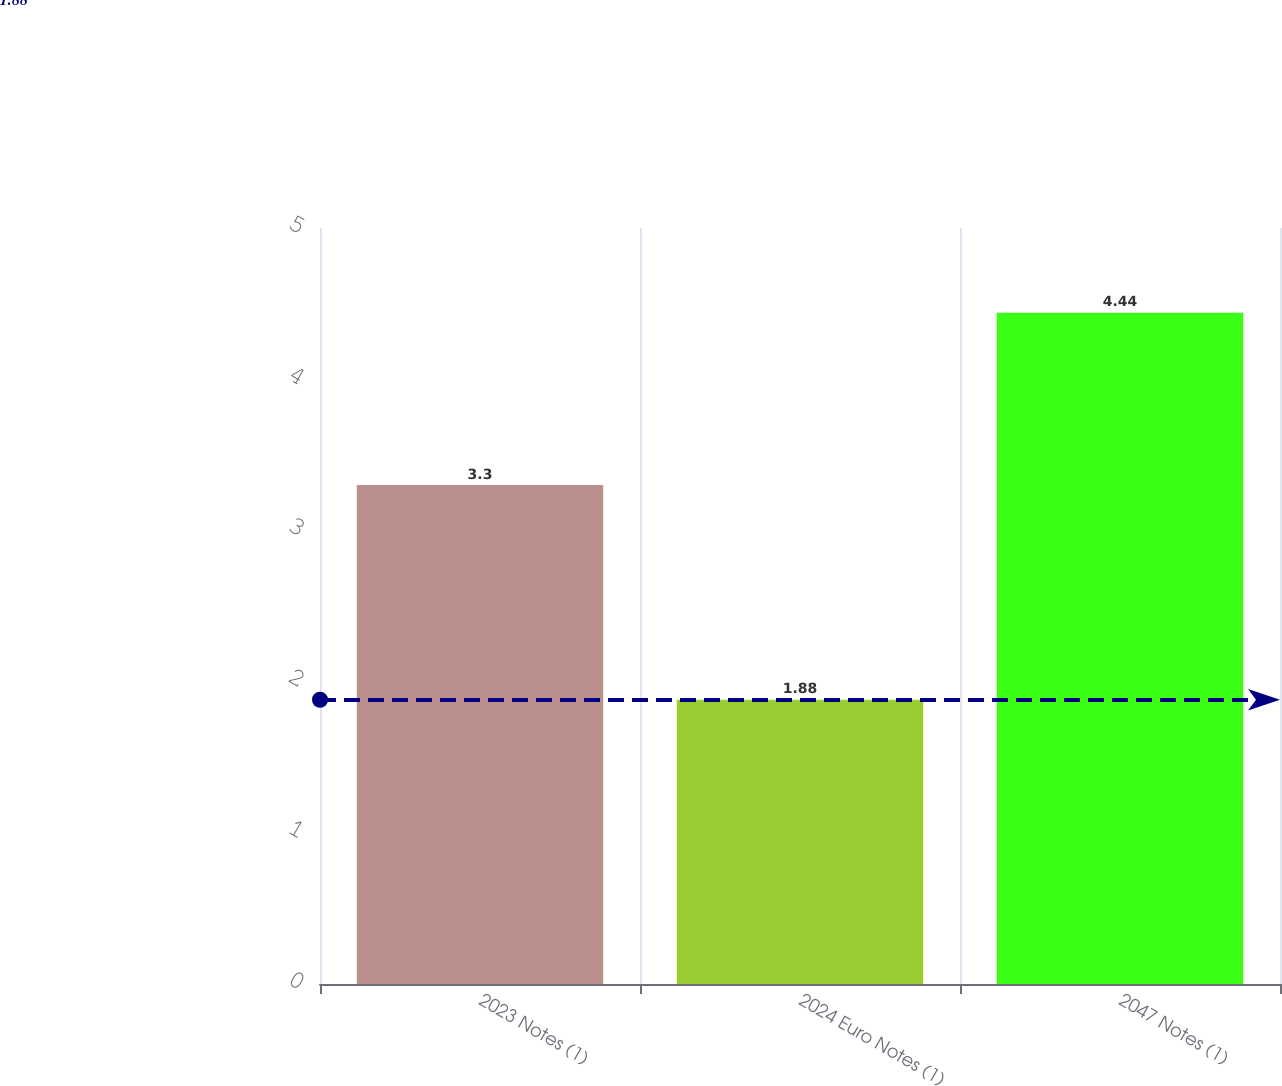<chart> <loc_0><loc_0><loc_500><loc_500><bar_chart><fcel>2023 Notes (1)<fcel>2024 Euro Notes (1)<fcel>2047 Notes (1)<nl><fcel>3.3<fcel>1.88<fcel>4.44<nl></chart> 